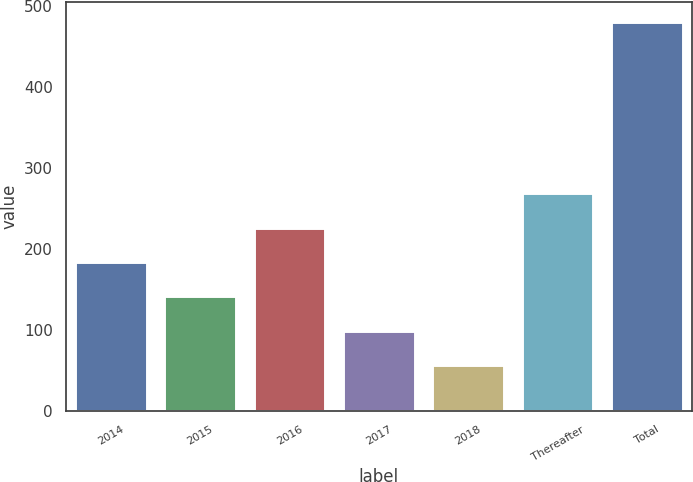<chart> <loc_0><loc_0><loc_500><loc_500><bar_chart><fcel>2014<fcel>2015<fcel>2016<fcel>2017<fcel>2018<fcel>Thereafter<fcel>Total<nl><fcel>184.2<fcel>141.8<fcel>226.6<fcel>99.4<fcel>57<fcel>269<fcel>481<nl></chart> 